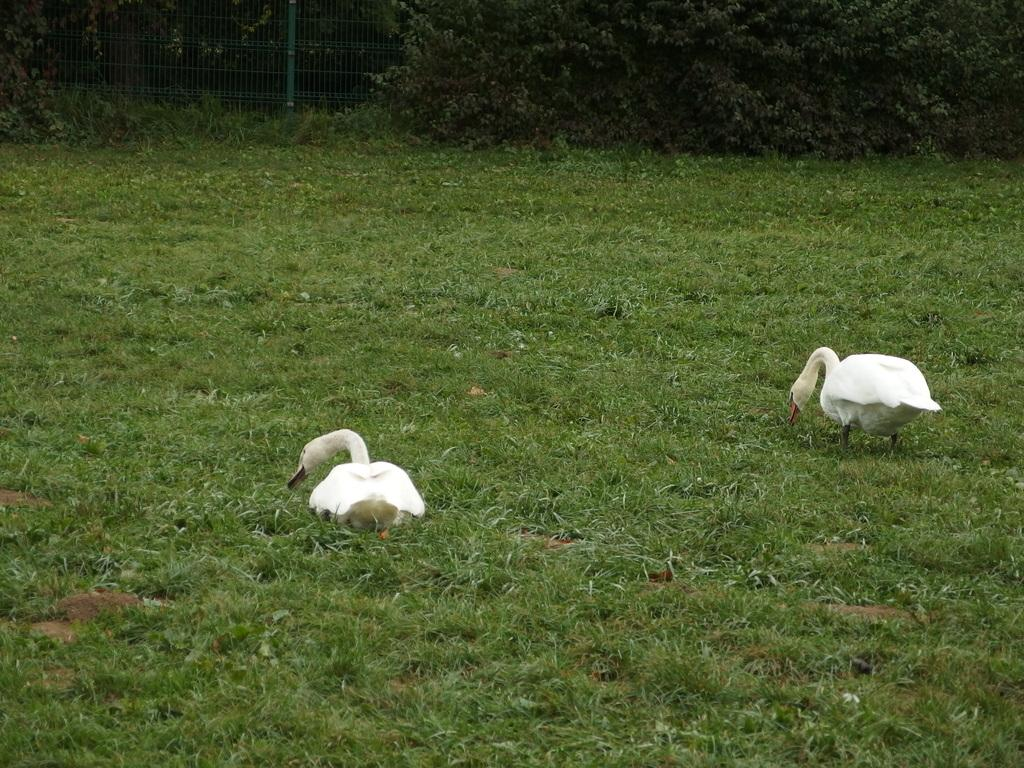What animals are in the center of the image? There are two swans in the center of the image. What type of terrain is visible at the bottom of the image? There is grass at the bottom of the image. What can be seen in the background of the image? There are plants and a fence in the background of the image. What type of writing can be seen on the swans' feet in the image? There is no writing visible on the swans' feet in the image. 